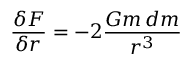<formula> <loc_0><loc_0><loc_500><loc_500>{ \frac { \delta F } { \delta r } } = - 2 { \frac { G m \, d m } { r ^ { 3 } } }</formula> 